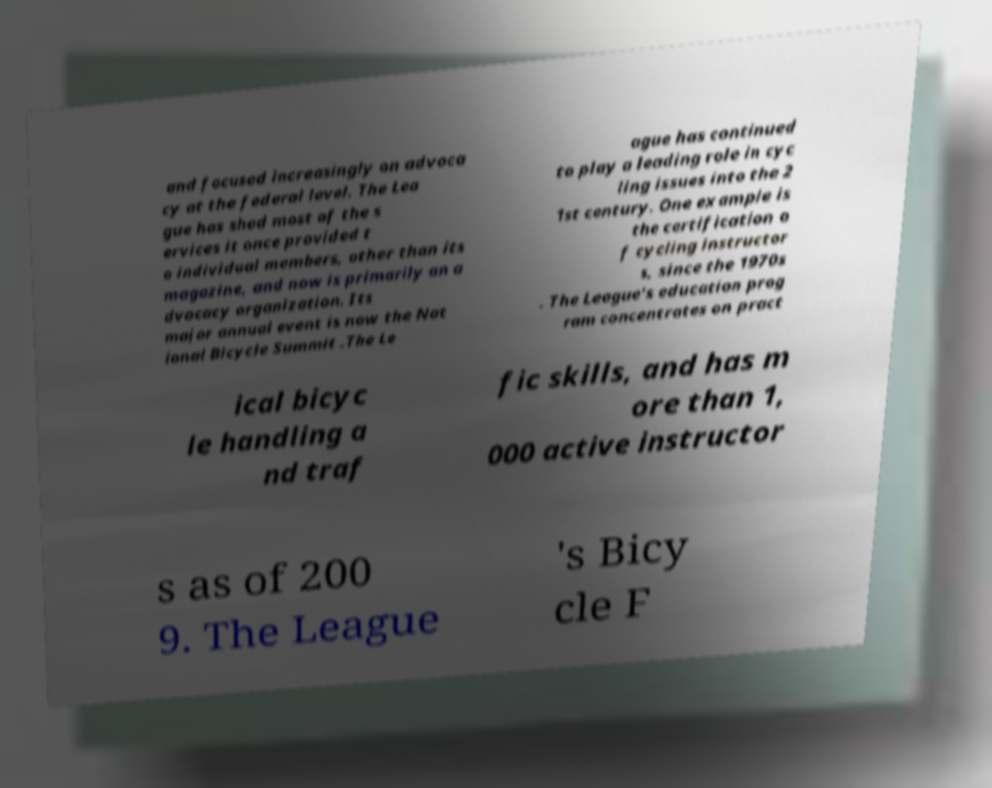What messages or text are displayed in this image? I need them in a readable, typed format. and focused increasingly on advoca cy at the federal level. The Lea gue has shed most of the s ervices it once provided t o individual members, other than its magazine, and now is primarily an a dvocacy organization. Its major annual event is now the Nat ional Bicycle Summit .The Le ague has continued to play a leading role in cyc ling issues into the 2 1st century. One example is the certification o f cycling instructor s, since the 1970s . The League's education prog ram concentrates on pract ical bicyc le handling a nd traf fic skills, and has m ore than 1, 000 active instructor s as of 200 9. The League 's Bicy cle F 